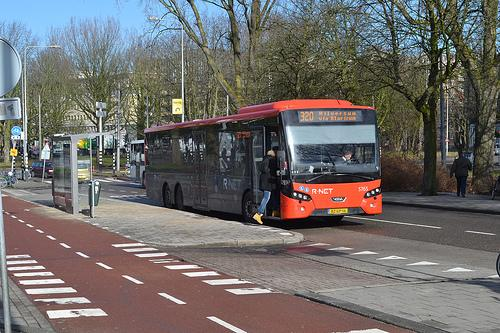Provide a brief description of the environment in the image. The image captures a local city street with a bus stopped at a metal and glass bus shelter, multiple street signs and yellow, blue traffic signs, and budding trees indicating it is spring or fall. Analyze any interaction between objects in the image. The person captured in a pair of blue jeans is boarding the bus through the bus door, while the bus is stopped at the curb near the bus shelter with the glass wall. In the context of object detection, how many objects with 'sign' are there in the image and describe them. There are 7 objects with 'sign' including: a yellow traffic sign, a blue traffic sign, street name signs, bus electronic destination sign, yellow sign on a pole, blue and white sign, and a digital sign on a bus. Evaluate the image quality from 1 to 5, with 1 being the worst and 5 being the best. The image quality is rated 4, as the information is clear but not every object has a perfect bounding box or positioning. Deduce the season of the year in the image based on the environment. It can be deduced that the season is either fall or spring since the trees do not have leaves and are budding. What color is the bus in the image and what is it doing? The bus is silver and orange, and it is stopped on the street with a person boarding it. What details can be gathered about the bus's identity from the image? The bus is a local community bus; it has an electronic destination sign, the number and destination visible on the bus, a red surface with white lines, and a license plate. Identify and describe the person on the sidewalk in the image. The person on the sidewalk is a man walking through some trees, wearing blue jeans and possibly getting on the bus. What is the visual sentiment indicated by the image? (e.g. Happy, Sad, etc.) The visual sentiment of the image is Neutral or Busy, as it shows a typical day on a city street with no specific emotions displayed. How many trees can be noticed in the image? There is one tall green budding tree in the image. 